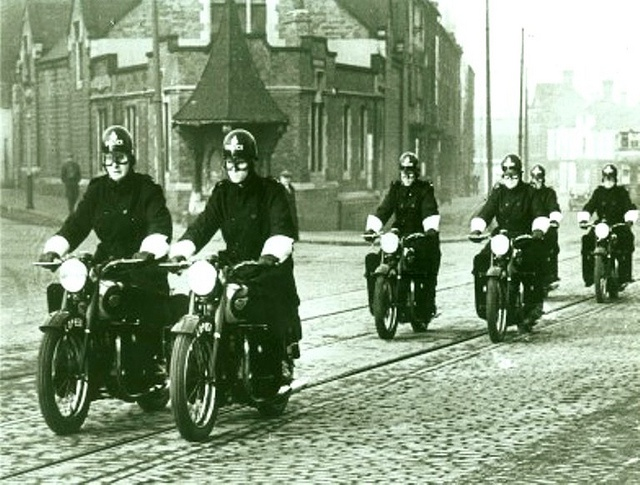Describe the objects in this image and their specific colors. I can see motorcycle in beige, darkgreen, and ivory tones, motorcycle in beige, darkgreen, and ivory tones, people in beige, darkgreen, and ivory tones, people in beige, darkgreen, and ivory tones, and people in beige, darkgreen, and ivory tones in this image. 